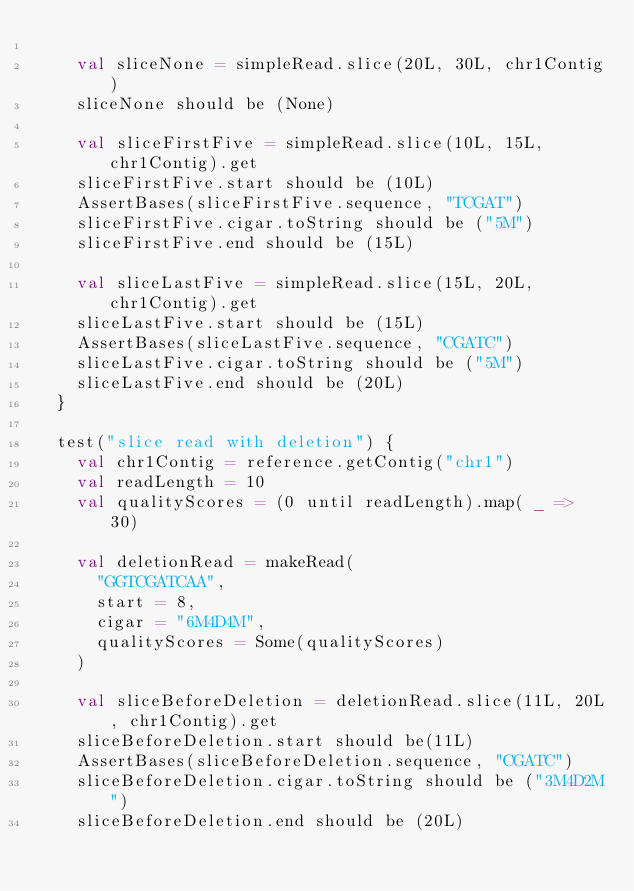Convert code to text. <code><loc_0><loc_0><loc_500><loc_500><_Scala_>
    val sliceNone = simpleRead.slice(20L, 30L, chr1Contig)
    sliceNone should be (None)

    val sliceFirstFive = simpleRead.slice(10L, 15L, chr1Contig).get
    sliceFirstFive.start should be (10L)
    AssertBases(sliceFirstFive.sequence, "TCGAT")
    sliceFirstFive.cigar.toString should be ("5M")
    sliceFirstFive.end should be (15L)

    val sliceLastFive = simpleRead.slice(15L, 20L, chr1Contig).get
    sliceLastFive.start should be (15L)
    AssertBases(sliceLastFive.sequence, "CGATC")
    sliceLastFive.cigar.toString should be ("5M")
    sliceLastFive.end should be (20L)
  }

  test("slice read with deletion") {
    val chr1Contig = reference.getContig("chr1")
    val readLength = 10
    val qualityScores = (0 until readLength).map( _ => 30)

    val deletionRead = makeRead(
      "GGTCGATCAA",
      start = 8,
      cigar = "6M4D4M",
      qualityScores = Some(qualityScores)
    )

    val sliceBeforeDeletion = deletionRead.slice(11L, 20L, chr1Contig).get
    sliceBeforeDeletion.start should be(11L)
    AssertBases(sliceBeforeDeletion.sequence, "CGATC")
    sliceBeforeDeletion.cigar.toString should be ("3M4D2M")
    sliceBeforeDeletion.end should be (20L)
</code> 